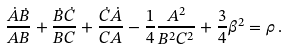Convert formula to latex. <formula><loc_0><loc_0><loc_500><loc_500>\frac { \dot { A } \dot { B } } { A B } + \frac { \dot { B } \dot { C } } { B C } + \frac { \dot { C } \dot { A } } { C A } - \frac { 1 } { 4 } \frac { A ^ { 2 } } { B ^ { 2 } C ^ { 2 } } + \frac { 3 } { 4 } \beta ^ { 2 } = \rho \, .</formula> 